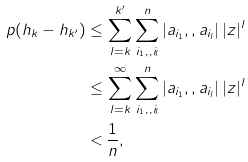<formula> <loc_0><loc_0><loc_500><loc_500>\ p ( h _ { k } - h _ { k ^ { \prime } } ) \leq & \, \sum _ { l = k } ^ { k ^ { \prime } } \sum _ { i _ { 1 } , , i _ { l } } ^ { n } | a _ { i _ { 1 } } , , a _ { i _ { l } } | \, | z | ^ { l } \\ \leq & \, \sum _ { l = k } ^ { \infty } \sum _ { i _ { 1 } , , i _ { l } } ^ { n } | a _ { i _ { 1 } } , , a _ { i _ { l } } | \, | z | ^ { l } \\ < & \, \frac { 1 } { n } ,</formula> 